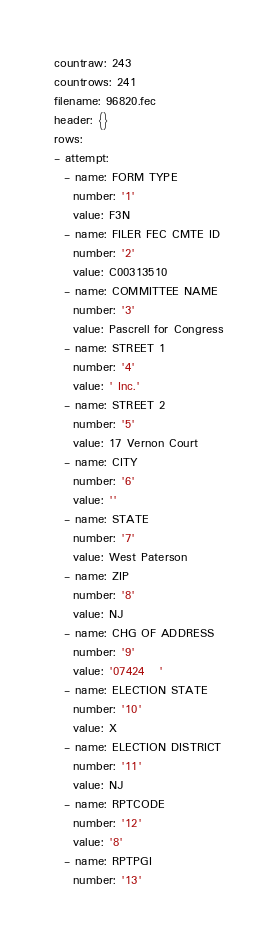<code> <loc_0><loc_0><loc_500><loc_500><_YAML_>countraw: 243
countrows: 241
filename: 96820.fec
header: {}
rows:
- attempt:
  - name: FORM TYPE
    number: '1'
    value: F3N
  - name: FILER FEC CMTE ID
    number: '2'
    value: C00313510
  - name: COMMITTEE NAME
    number: '3'
    value: Pascrell for Congress
  - name: STREET 1
    number: '4'
    value: ' Inc.'
  - name: STREET 2
    number: '5'
    value: 17 Vernon Court
  - name: CITY
    number: '6'
    value: ''
  - name: STATE
    number: '7'
    value: West Paterson
  - name: ZIP
    number: '8'
    value: NJ
  - name: CHG OF ADDRESS
    number: '9'
    value: '07424   '
  - name: ELECTION STATE
    number: '10'
    value: X
  - name: ELECTION DISTRICT
    number: '11'
    value: NJ
  - name: RPTCODE
    number: '12'
    value: '8'
  - name: RPTPGI
    number: '13'</code> 